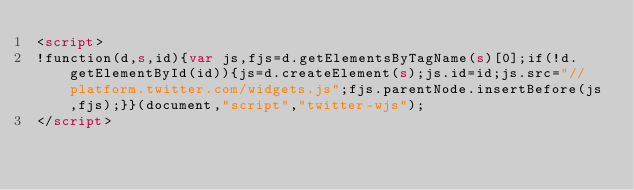<code> <loc_0><loc_0><loc_500><loc_500><_HTML_><script>
!function(d,s,id){var js,fjs=d.getElementsByTagName(s)[0];if(!d.getElementById(id)){js=d.createElement(s);js.id=id;js.src="//platform.twitter.com/widgets.js";fjs.parentNode.insertBefore(js,fjs);}}(document,"script","twitter-wjs");
</script>
</code> 